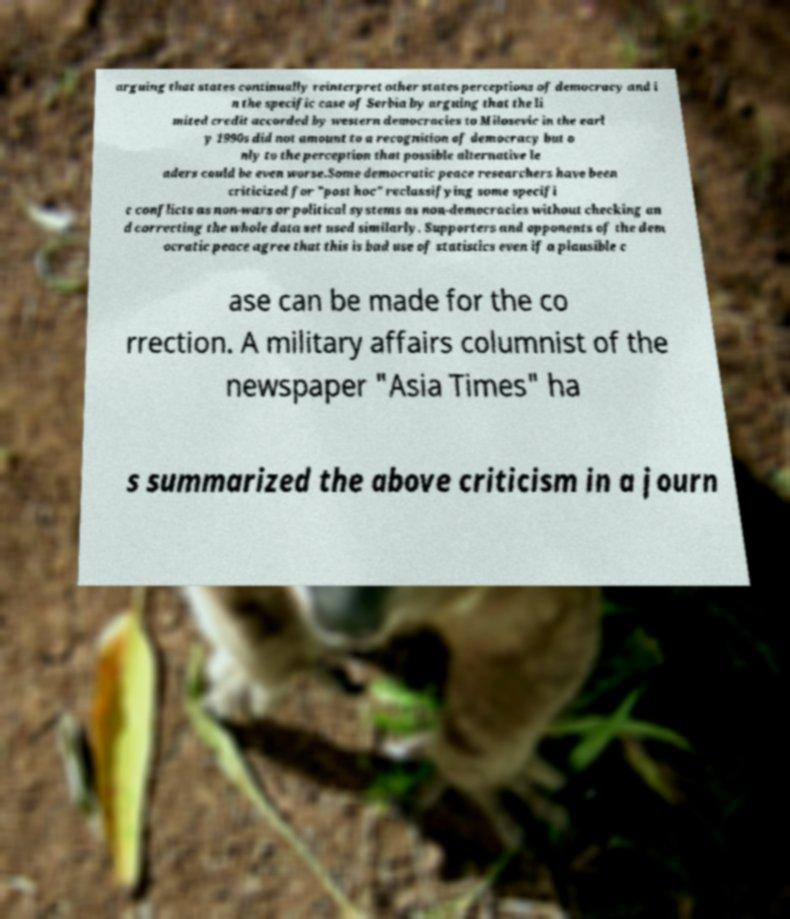Could you assist in decoding the text presented in this image and type it out clearly? arguing that states continually reinterpret other states perceptions of democracy and i n the specific case of Serbia by arguing that the li mited credit accorded by western democracies to Milosevic in the earl y 1990s did not amount to a recognition of democracy but o nly to the perception that possible alternative le aders could be even worse.Some democratic peace researchers have been criticized for "post hoc" reclassifying some specifi c conflicts as non-wars or political systems as non-democracies without checking an d correcting the whole data set used similarly. Supporters and opponents of the dem ocratic peace agree that this is bad use of statistics even if a plausible c ase can be made for the co rrection. A military affairs columnist of the newspaper "Asia Times" ha s summarized the above criticism in a journ 